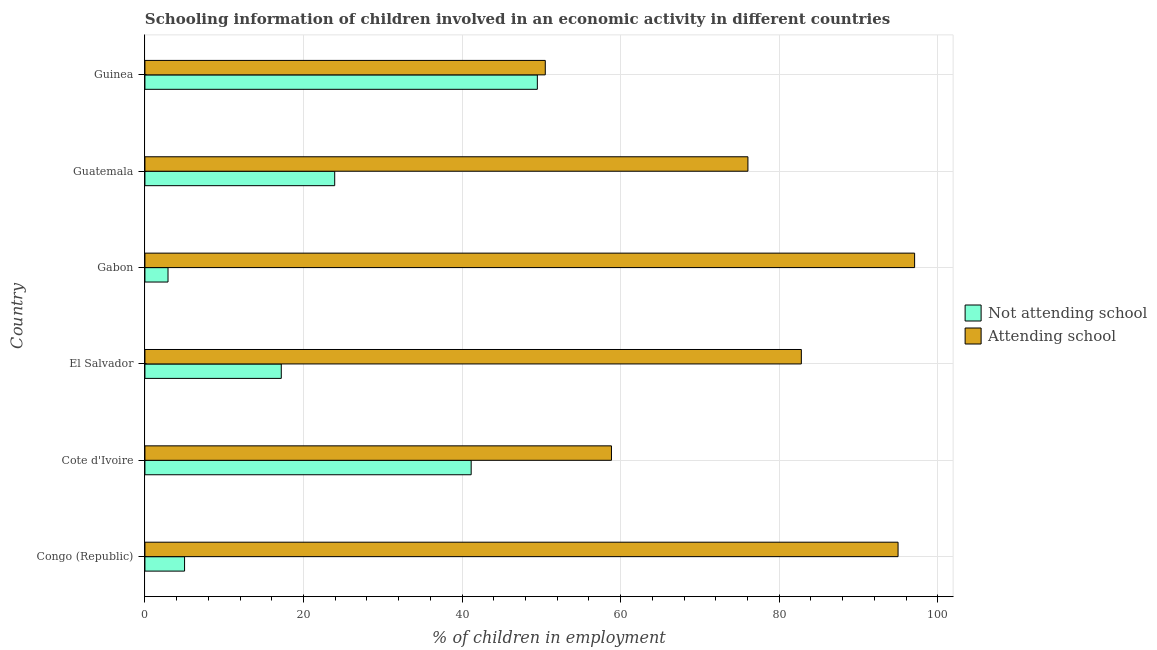Are the number of bars per tick equal to the number of legend labels?
Provide a short and direct response. Yes. Are the number of bars on each tick of the Y-axis equal?
Keep it short and to the point. Yes. How many bars are there on the 4th tick from the top?
Your answer should be very brief. 2. What is the label of the 2nd group of bars from the top?
Your answer should be very brief. Guatemala. What is the percentage of employed children who are not attending school in Cote d'Ivoire?
Offer a terse response. 41.15. Across all countries, what is the maximum percentage of employed children who are not attending school?
Provide a short and direct response. 49.5. Across all countries, what is the minimum percentage of employed children who are attending school?
Offer a very short reply. 50.5. In which country was the percentage of employed children who are not attending school maximum?
Offer a terse response. Guinea. In which country was the percentage of employed children who are not attending school minimum?
Your answer should be compact. Gabon. What is the total percentage of employed children who are attending school in the graph?
Offer a terse response. 460.3. What is the difference between the percentage of employed children who are not attending school in Congo (Republic) and that in Cote d'Ivoire?
Your answer should be very brief. -36.15. What is the difference between the percentage of employed children who are attending school in Guinea and the percentage of employed children who are not attending school in El Salvador?
Your response must be concise. 33.3. What is the average percentage of employed children who are not attending school per country?
Provide a succinct answer. 23.28. What is the difference between the percentage of employed children who are not attending school and percentage of employed children who are attending school in Gabon?
Your answer should be compact. -94.17. What is the ratio of the percentage of employed children who are not attending school in Gabon to that in Guatemala?
Provide a short and direct response. 0.12. What is the difference between the highest and the second highest percentage of employed children who are not attending school?
Provide a short and direct response. 8.35. What is the difference between the highest and the lowest percentage of employed children who are not attending school?
Give a very brief answer. 46.59. In how many countries, is the percentage of employed children who are attending school greater than the average percentage of employed children who are attending school taken over all countries?
Your answer should be very brief. 3. Is the sum of the percentage of employed children who are attending school in Congo (Republic) and Guinea greater than the maximum percentage of employed children who are not attending school across all countries?
Offer a terse response. Yes. What does the 1st bar from the top in Gabon represents?
Ensure brevity in your answer.  Attending school. What does the 2nd bar from the bottom in Guatemala represents?
Give a very brief answer. Attending school. How many bars are there?
Offer a very short reply. 12. How many countries are there in the graph?
Your response must be concise. 6. What is the difference between two consecutive major ticks on the X-axis?
Ensure brevity in your answer.  20. Are the values on the major ticks of X-axis written in scientific E-notation?
Give a very brief answer. No. Does the graph contain grids?
Give a very brief answer. Yes. How many legend labels are there?
Give a very brief answer. 2. How are the legend labels stacked?
Provide a succinct answer. Vertical. What is the title of the graph?
Your response must be concise. Schooling information of children involved in an economic activity in different countries. Does "Central government" appear as one of the legend labels in the graph?
Keep it short and to the point. No. What is the label or title of the X-axis?
Your answer should be compact. % of children in employment. What is the label or title of the Y-axis?
Your answer should be very brief. Country. What is the % of children in employment of Not attending school in Cote d'Ivoire?
Give a very brief answer. 41.15. What is the % of children in employment in Attending school in Cote d'Ivoire?
Keep it short and to the point. 58.85. What is the % of children in employment in Attending school in El Salvador?
Offer a very short reply. 82.8. What is the % of children in employment in Not attending school in Gabon?
Give a very brief answer. 2.91. What is the % of children in employment of Attending school in Gabon?
Provide a short and direct response. 97.09. What is the % of children in employment in Not attending school in Guatemala?
Offer a terse response. 23.94. What is the % of children in employment of Attending school in Guatemala?
Provide a succinct answer. 76.06. What is the % of children in employment of Not attending school in Guinea?
Make the answer very short. 49.5. What is the % of children in employment in Attending school in Guinea?
Keep it short and to the point. 50.5. Across all countries, what is the maximum % of children in employment in Not attending school?
Keep it short and to the point. 49.5. Across all countries, what is the maximum % of children in employment of Attending school?
Offer a terse response. 97.09. Across all countries, what is the minimum % of children in employment in Not attending school?
Provide a succinct answer. 2.91. Across all countries, what is the minimum % of children in employment in Attending school?
Offer a terse response. 50.5. What is the total % of children in employment of Not attending school in the graph?
Make the answer very short. 139.7. What is the total % of children in employment in Attending school in the graph?
Your answer should be very brief. 460.3. What is the difference between the % of children in employment of Not attending school in Congo (Republic) and that in Cote d'Ivoire?
Your answer should be very brief. -36.15. What is the difference between the % of children in employment in Attending school in Congo (Republic) and that in Cote d'Ivoire?
Ensure brevity in your answer.  36.15. What is the difference between the % of children in employment of Attending school in Congo (Republic) and that in El Salvador?
Provide a short and direct response. 12.2. What is the difference between the % of children in employment of Not attending school in Congo (Republic) and that in Gabon?
Make the answer very short. 2.09. What is the difference between the % of children in employment of Attending school in Congo (Republic) and that in Gabon?
Offer a very short reply. -2.09. What is the difference between the % of children in employment in Not attending school in Congo (Republic) and that in Guatemala?
Keep it short and to the point. -18.94. What is the difference between the % of children in employment in Attending school in Congo (Republic) and that in Guatemala?
Your response must be concise. 18.94. What is the difference between the % of children in employment of Not attending school in Congo (Republic) and that in Guinea?
Make the answer very short. -44.5. What is the difference between the % of children in employment in Attending school in Congo (Republic) and that in Guinea?
Your answer should be very brief. 44.5. What is the difference between the % of children in employment in Not attending school in Cote d'Ivoire and that in El Salvador?
Keep it short and to the point. 23.95. What is the difference between the % of children in employment in Attending school in Cote d'Ivoire and that in El Salvador?
Offer a very short reply. -23.95. What is the difference between the % of children in employment of Not attending school in Cote d'Ivoire and that in Gabon?
Keep it short and to the point. 38.24. What is the difference between the % of children in employment in Attending school in Cote d'Ivoire and that in Gabon?
Keep it short and to the point. -38.24. What is the difference between the % of children in employment in Not attending school in Cote d'Ivoire and that in Guatemala?
Provide a succinct answer. 17.21. What is the difference between the % of children in employment in Attending school in Cote d'Ivoire and that in Guatemala?
Your answer should be very brief. -17.21. What is the difference between the % of children in employment of Not attending school in Cote d'Ivoire and that in Guinea?
Your answer should be compact. -8.35. What is the difference between the % of children in employment in Attending school in Cote d'Ivoire and that in Guinea?
Your response must be concise. 8.35. What is the difference between the % of children in employment of Not attending school in El Salvador and that in Gabon?
Provide a succinct answer. 14.29. What is the difference between the % of children in employment in Attending school in El Salvador and that in Gabon?
Offer a terse response. -14.29. What is the difference between the % of children in employment in Not attending school in El Salvador and that in Guatemala?
Your answer should be compact. -6.74. What is the difference between the % of children in employment of Attending school in El Salvador and that in Guatemala?
Provide a short and direct response. 6.74. What is the difference between the % of children in employment of Not attending school in El Salvador and that in Guinea?
Your answer should be compact. -32.3. What is the difference between the % of children in employment of Attending school in El Salvador and that in Guinea?
Offer a terse response. 32.3. What is the difference between the % of children in employment in Not attending school in Gabon and that in Guatemala?
Your answer should be very brief. -21.03. What is the difference between the % of children in employment in Attending school in Gabon and that in Guatemala?
Your answer should be very brief. 21.03. What is the difference between the % of children in employment in Not attending school in Gabon and that in Guinea?
Keep it short and to the point. -46.59. What is the difference between the % of children in employment in Attending school in Gabon and that in Guinea?
Give a very brief answer. 46.59. What is the difference between the % of children in employment of Not attending school in Guatemala and that in Guinea?
Provide a short and direct response. -25.56. What is the difference between the % of children in employment of Attending school in Guatemala and that in Guinea?
Your answer should be compact. 25.56. What is the difference between the % of children in employment in Not attending school in Congo (Republic) and the % of children in employment in Attending school in Cote d'Ivoire?
Keep it short and to the point. -53.85. What is the difference between the % of children in employment in Not attending school in Congo (Republic) and the % of children in employment in Attending school in El Salvador?
Your response must be concise. -77.8. What is the difference between the % of children in employment in Not attending school in Congo (Republic) and the % of children in employment in Attending school in Gabon?
Offer a very short reply. -92.09. What is the difference between the % of children in employment in Not attending school in Congo (Republic) and the % of children in employment in Attending school in Guatemala?
Your response must be concise. -71.06. What is the difference between the % of children in employment of Not attending school in Congo (Republic) and the % of children in employment of Attending school in Guinea?
Your response must be concise. -45.5. What is the difference between the % of children in employment in Not attending school in Cote d'Ivoire and the % of children in employment in Attending school in El Salvador?
Keep it short and to the point. -41.65. What is the difference between the % of children in employment in Not attending school in Cote d'Ivoire and the % of children in employment in Attending school in Gabon?
Keep it short and to the point. -55.93. What is the difference between the % of children in employment of Not attending school in Cote d'Ivoire and the % of children in employment of Attending school in Guatemala?
Give a very brief answer. -34.91. What is the difference between the % of children in employment in Not attending school in Cote d'Ivoire and the % of children in employment in Attending school in Guinea?
Provide a succinct answer. -9.35. What is the difference between the % of children in employment in Not attending school in El Salvador and the % of children in employment in Attending school in Gabon?
Your answer should be very brief. -79.89. What is the difference between the % of children in employment of Not attending school in El Salvador and the % of children in employment of Attending school in Guatemala?
Give a very brief answer. -58.86. What is the difference between the % of children in employment of Not attending school in El Salvador and the % of children in employment of Attending school in Guinea?
Offer a terse response. -33.3. What is the difference between the % of children in employment in Not attending school in Gabon and the % of children in employment in Attending school in Guatemala?
Keep it short and to the point. -73.15. What is the difference between the % of children in employment in Not attending school in Gabon and the % of children in employment in Attending school in Guinea?
Provide a succinct answer. -47.59. What is the difference between the % of children in employment in Not attending school in Guatemala and the % of children in employment in Attending school in Guinea?
Offer a terse response. -26.56. What is the average % of children in employment of Not attending school per country?
Provide a short and direct response. 23.28. What is the average % of children in employment of Attending school per country?
Give a very brief answer. 76.72. What is the difference between the % of children in employment of Not attending school and % of children in employment of Attending school in Congo (Republic)?
Give a very brief answer. -90. What is the difference between the % of children in employment of Not attending school and % of children in employment of Attending school in Cote d'Ivoire?
Keep it short and to the point. -17.69. What is the difference between the % of children in employment of Not attending school and % of children in employment of Attending school in El Salvador?
Offer a very short reply. -65.6. What is the difference between the % of children in employment of Not attending school and % of children in employment of Attending school in Gabon?
Offer a very short reply. -94.17. What is the difference between the % of children in employment of Not attending school and % of children in employment of Attending school in Guatemala?
Your response must be concise. -52.12. What is the difference between the % of children in employment of Not attending school and % of children in employment of Attending school in Guinea?
Give a very brief answer. -1. What is the ratio of the % of children in employment of Not attending school in Congo (Republic) to that in Cote d'Ivoire?
Offer a very short reply. 0.12. What is the ratio of the % of children in employment of Attending school in Congo (Republic) to that in Cote d'Ivoire?
Offer a very short reply. 1.61. What is the ratio of the % of children in employment of Not attending school in Congo (Republic) to that in El Salvador?
Give a very brief answer. 0.29. What is the ratio of the % of children in employment of Attending school in Congo (Republic) to that in El Salvador?
Your answer should be very brief. 1.15. What is the ratio of the % of children in employment in Not attending school in Congo (Republic) to that in Gabon?
Offer a very short reply. 1.72. What is the ratio of the % of children in employment of Attending school in Congo (Republic) to that in Gabon?
Keep it short and to the point. 0.98. What is the ratio of the % of children in employment of Not attending school in Congo (Republic) to that in Guatemala?
Your answer should be very brief. 0.21. What is the ratio of the % of children in employment in Attending school in Congo (Republic) to that in Guatemala?
Your response must be concise. 1.25. What is the ratio of the % of children in employment in Not attending school in Congo (Republic) to that in Guinea?
Your answer should be very brief. 0.1. What is the ratio of the % of children in employment in Attending school in Congo (Republic) to that in Guinea?
Your response must be concise. 1.88. What is the ratio of the % of children in employment in Not attending school in Cote d'Ivoire to that in El Salvador?
Your answer should be very brief. 2.39. What is the ratio of the % of children in employment of Attending school in Cote d'Ivoire to that in El Salvador?
Provide a succinct answer. 0.71. What is the ratio of the % of children in employment of Not attending school in Cote d'Ivoire to that in Gabon?
Provide a succinct answer. 14.13. What is the ratio of the % of children in employment in Attending school in Cote d'Ivoire to that in Gabon?
Provide a short and direct response. 0.61. What is the ratio of the % of children in employment of Not attending school in Cote d'Ivoire to that in Guatemala?
Offer a terse response. 1.72. What is the ratio of the % of children in employment in Attending school in Cote d'Ivoire to that in Guatemala?
Give a very brief answer. 0.77. What is the ratio of the % of children in employment in Not attending school in Cote d'Ivoire to that in Guinea?
Keep it short and to the point. 0.83. What is the ratio of the % of children in employment in Attending school in Cote d'Ivoire to that in Guinea?
Keep it short and to the point. 1.17. What is the ratio of the % of children in employment in Not attending school in El Salvador to that in Gabon?
Offer a terse response. 5.91. What is the ratio of the % of children in employment in Attending school in El Salvador to that in Gabon?
Make the answer very short. 0.85. What is the ratio of the % of children in employment of Not attending school in El Salvador to that in Guatemala?
Give a very brief answer. 0.72. What is the ratio of the % of children in employment in Attending school in El Salvador to that in Guatemala?
Make the answer very short. 1.09. What is the ratio of the % of children in employment in Not attending school in El Salvador to that in Guinea?
Provide a short and direct response. 0.35. What is the ratio of the % of children in employment of Attending school in El Salvador to that in Guinea?
Ensure brevity in your answer.  1.64. What is the ratio of the % of children in employment in Not attending school in Gabon to that in Guatemala?
Your answer should be very brief. 0.12. What is the ratio of the % of children in employment of Attending school in Gabon to that in Guatemala?
Give a very brief answer. 1.28. What is the ratio of the % of children in employment of Not attending school in Gabon to that in Guinea?
Make the answer very short. 0.06. What is the ratio of the % of children in employment in Attending school in Gabon to that in Guinea?
Make the answer very short. 1.92. What is the ratio of the % of children in employment of Not attending school in Guatemala to that in Guinea?
Give a very brief answer. 0.48. What is the ratio of the % of children in employment of Attending school in Guatemala to that in Guinea?
Your answer should be very brief. 1.51. What is the difference between the highest and the second highest % of children in employment of Not attending school?
Ensure brevity in your answer.  8.35. What is the difference between the highest and the second highest % of children in employment in Attending school?
Your answer should be compact. 2.09. What is the difference between the highest and the lowest % of children in employment of Not attending school?
Your answer should be very brief. 46.59. What is the difference between the highest and the lowest % of children in employment of Attending school?
Provide a succinct answer. 46.59. 